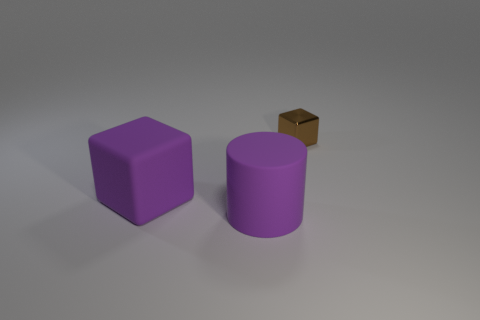There is a large purple object behind the matte cylinder; what shape is it?
Your answer should be compact. Cube. There is a big object on the right side of the block that is left of the small metallic block; how many large cylinders are in front of it?
Provide a short and direct response. 0. There is a rubber cube; is its size the same as the thing to the right of the large matte cylinder?
Provide a succinct answer. No. What is the size of the thing that is right of the purple rubber object that is in front of the large purple cube?
Your answer should be compact. Small. How many big purple blocks have the same material as the brown object?
Your response must be concise. 0. Are there any purple cylinders?
Keep it short and to the point. Yes. What size is the purple matte object that is right of the large purple rubber block?
Provide a succinct answer. Large. What number of other shiny blocks are the same color as the tiny block?
Your answer should be very brief. 0. How many blocks are either red objects or brown metal things?
Provide a succinct answer. 1. What shape is the thing that is both right of the large cube and to the left of the metal object?
Offer a terse response. Cylinder. 